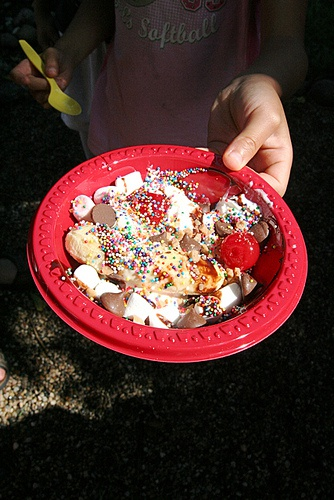Describe the objects in this image and their specific colors. I can see bowl in black, red, white, and brown tones, people in black, maroon, and tan tones, banana in black, beige, and tan tones, spoon in black and olive tones, and banana in black, white, orange, tan, and salmon tones in this image. 